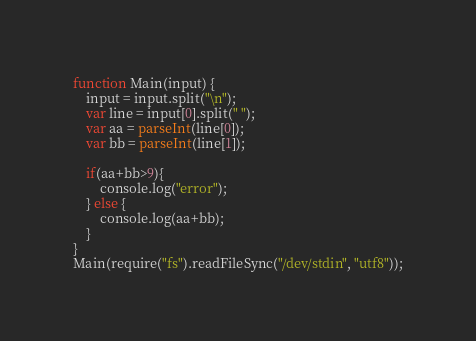Convert code to text. <code><loc_0><loc_0><loc_500><loc_500><_JavaScript_>function Main(input) {
    input = input.split("\n");
    var line = input[0].split(" ");
    var aa = parseInt(line[0]);
    var bb = parseInt(line[1]);
    
    if(aa+bb>9){
        console.log("error");
    } else {
        console.log(aa+bb);
    }
}
Main(require("fs").readFileSync("/dev/stdin", "utf8"));</code> 